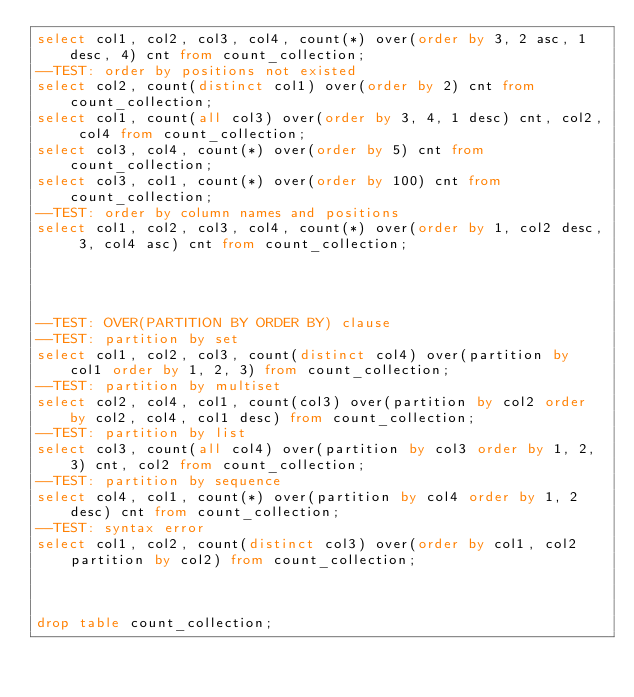Convert code to text. <code><loc_0><loc_0><loc_500><loc_500><_SQL_>select col1, col2, col3, col4, count(*) over(order by 3, 2 asc, 1 desc, 4) cnt from count_collection;
--TEST: order by positions not existed
select col2, count(distinct col1) over(order by 2) cnt from count_collection;
select col1, count(all col3) over(order by 3, 4, 1 desc) cnt, col2, col4 from count_collection;
select col3, col4, count(*) over(order by 5) cnt from count_collection;
select col3, col1, count(*) over(order by 100) cnt from count_collection;
--TEST: order by column names and positions
select col1, col2, col3, col4, count(*) over(order by 1, col2 desc, 3, col4 asc) cnt from count_collection;




--TEST: OVER(PARTITION BY ORDER BY) clause
--TEST: partition by set
select col1, col2, col3, count(distinct col4) over(partition by col1 order by 1, 2, 3) from count_collection;
--TEST: partition by multiset
select col2, col4, col1, count(col3) over(partition by col2 order by col2, col4, col1 desc) from count_collection;
--TEST: partition by list
select col3, count(all col4) over(partition by col3 order by 1, 2, 3) cnt, col2 from count_collection;
--TEST: partition by sequence
select col4, col1, count(*) over(partition by col4 order by 1, 2 desc) cnt from count_collection;
--TEST: syntax error
select col1, col2, count(distinct col3) over(order by col1, col2 partition by col2) from count_collection;



drop table count_collection; 















</code> 